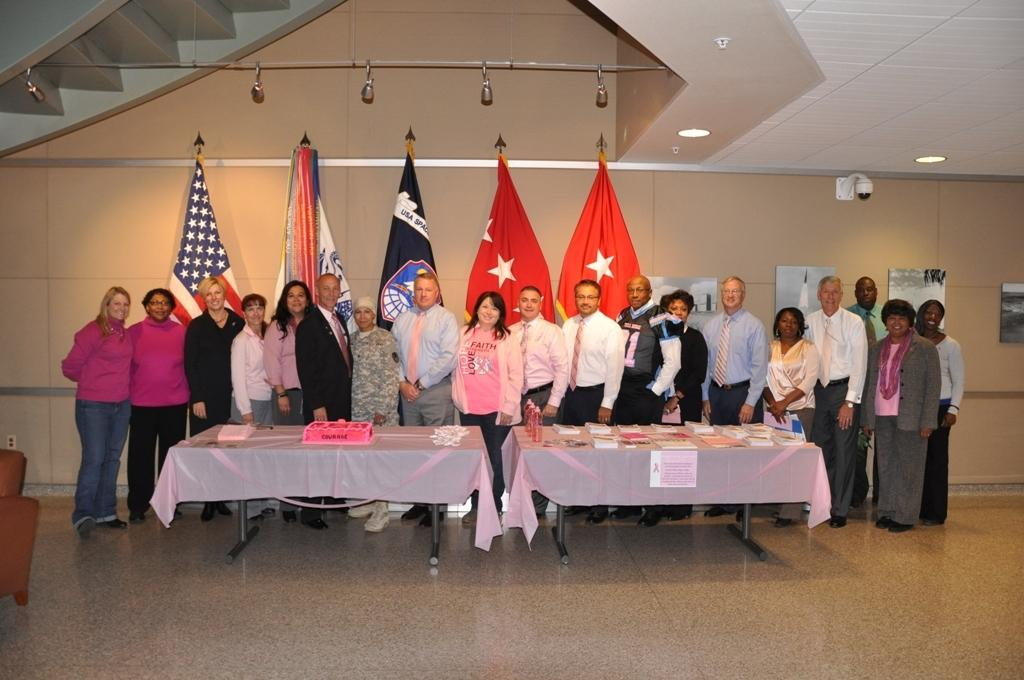What is happening in the image? There are many people standing in front of a table. What can be seen on the wall behind the people? There are flags on the wall behind the people. What type of vegetable is being used as a decoration on the table? There is no vegetable present on the table in the image. What color is the cloud in the image? There is no cloud visible in the image. 